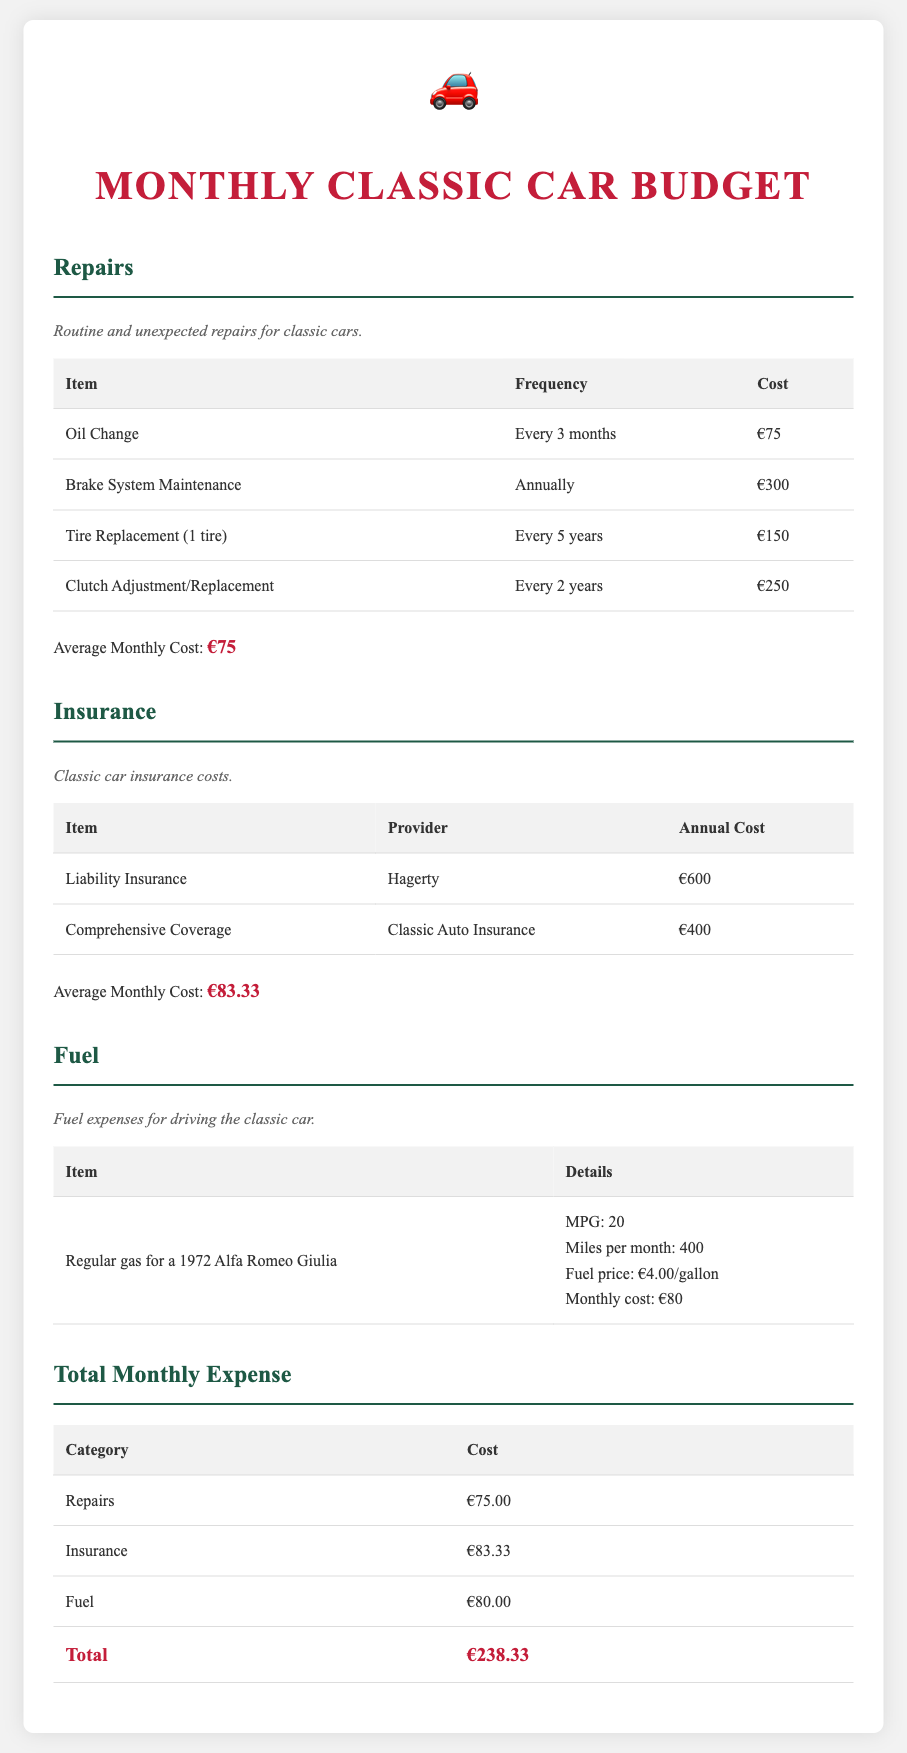what is the average monthly cost for repairs? The average monthly cost for repairs is detailed in the repairs section of the document and is listed as €75.
Answer: €75 who provides the comprehensive coverage insurance? The table in the insurance section lists the provider for comprehensive coverage insurance as Classic Auto Insurance.
Answer: Classic Auto Insurance how much do the repairs cost for clutch adjustment/replacement? The repairs section states that the cost for clutch adjustment/replacement is €250, but it's also specified that this is every 2 years.
Answer: €250 what is the total monthly maintenance expense? The total monthly expense is calculated in the total section, where it states the sum of all categories is €238.33.
Answer: €238.33 what is the average monthly cost for fuel? The document mentions the fuel monthly cost for the classic car as €80, provided in the fuel section.
Answer: €80 how often is the brake system maintenance required? The frequency for brake system maintenance is stated as annually in the repairs section.
Answer: Annually what is the cost of liability insurance? The annual cost for liability insurance is listed under the insurance section as €600.
Answer: €600 how many miles per month does the classic car typically drive? The fuel section mentions that the classic car drives 400 miles per month.
Answer: 400 miles what is the cost of one tire replacement? According to the repairs section, the cost for one tire replacement is €150.
Answer: €150 